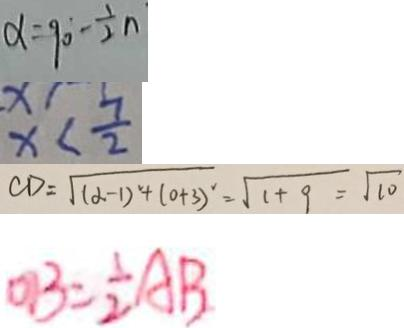Convert formula to latex. <formula><loc_0><loc_0><loc_500><loc_500>\alpha = 9 0 - \frac { 1 } { 2 } n 
 x < \frac { 7 } { 2 } 
 C D = \sqrt { ( d - 1 ) ^ { 2 } + ( 0 + 3 ) ^ { 2 } } = \sqrt { 1 + 9 } = \sqrt { 1 0 } 
 O B = \frac { 1 } { 2 } A B</formula> 